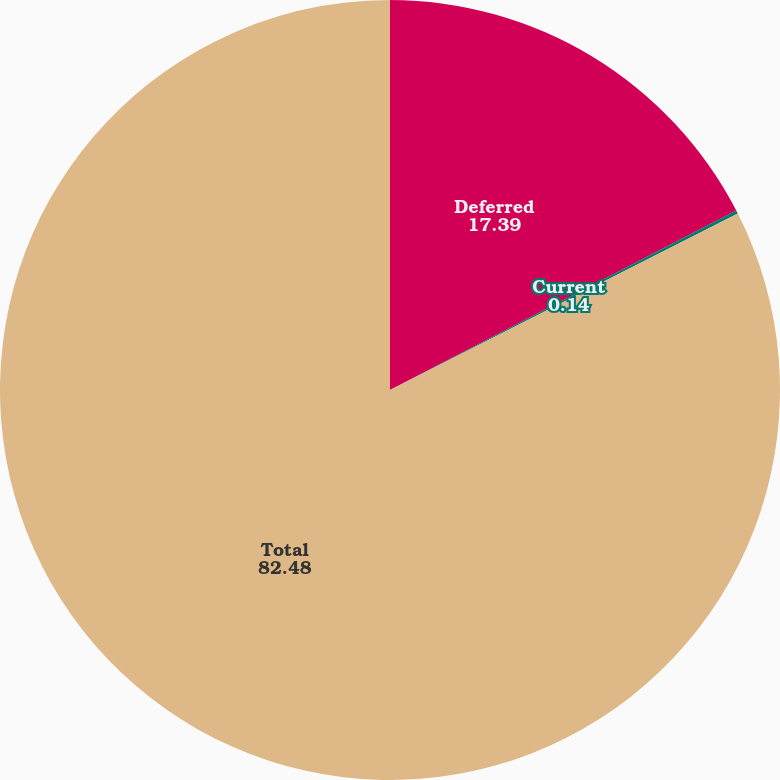Convert chart to OTSL. <chart><loc_0><loc_0><loc_500><loc_500><pie_chart><fcel>Deferred<fcel>Current<fcel>Total<nl><fcel>17.39%<fcel>0.14%<fcel>82.48%<nl></chart> 